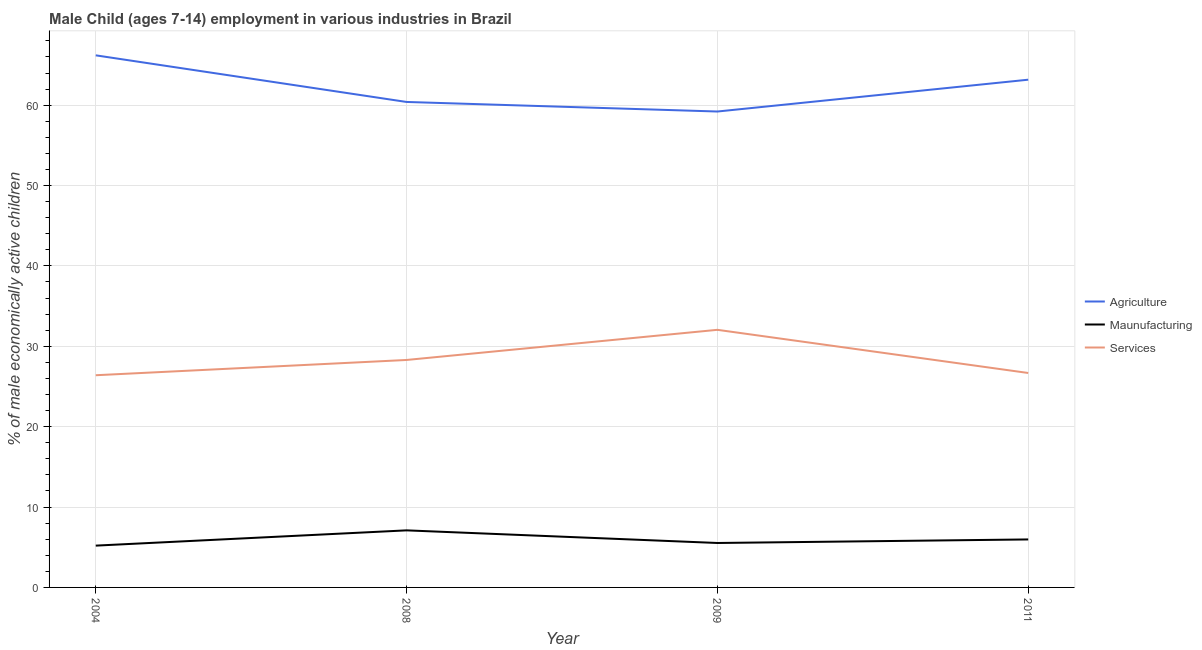What is the percentage of economically active children in agriculture in 2004?
Give a very brief answer. 66.2. Across all years, what is the maximum percentage of economically active children in agriculture?
Provide a short and direct response. 66.2. Across all years, what is the minimum percentage of economically active children in services?
Offer a very short reply. 26.4. What is the total percentage of economically active children in manufacturing in the graph?
Your answer should be very brief. 23.8. What is the difference between the percentage of economically active children in agriculture in 2009 and that in 2011?
Offer a very short reply. -3.96. What is the difference between the percentage of economically active children in agriculture in 2011 and the percentage of economically active children in services in 2009?
Give a very brief answer. 31.12. What is the average percentage of economically active children in agriculture per year?
Provide a short and direct response. 62.25. In the year 2011, what is the difference between the percentage of economically active children in agriculture and percentage of economically active children in manufacturing?
Your response must be concise. 57.2. In how many years, is the percentage of economically active children in services greater than 8 %?
Keep it short and to the point. 4. What is the ratio of the percentage of economically active children in services in 2009 to that in 2011?
Provide a succinct answer. 1.2. Is the difference between the percentage of economically active children in manufacturing in 2004 and 2009 greater than the difference between the percentage of economically active children in services in 2004 and 2009?
Offer a very short reply. Yes. What is the difference between the highest and the second highest percentage of economically active children in services?
Your response must be concise. 3.75. What is the difference between the highest and the lowest percentage of economically active children in manufacturing?
Ensure brevity in your answer.  1.9. In how many years, is the percentage of economically active children in manufacturing greater than the average percentage of economically active children in manufacturing taken over all years?
Offer a very short reply. 2. Is the sum of the percentage of economically active children in agriculture in 2004 and 2011 greater than the maximum percentage of economically active children in manufacturing across all years?
Provide a short and direct response. Yes. Does the percentage of economically active children in manufacturing monotonically increase over the years?
Offer a very short reply. No. Is the percentage of economically active children in services strictly greater than the percentage of economically active children in manufacturing over the years?
Provide a succinct answer. Yes. How many years are there in the graph?
Provide a short and direct response. 4. What is the difference between two consecutive major ticks on the Y-axis?
Keep it short and to the point. 10. Are the values on the major ticks of Y-axis written in scientific E-notation?
Offer a very short reply. No. Does the graph contain any zero values?
Provide a succinct answer. No. Does the graph contain grids?
Provide a short and direct response. Yes. How many legend labels are there?
Your answer should be compact. 3. How are the legend labels stacked?
Your answer should be very brief. Vertical. What is the title of the graph?
Your answer should be very brief. Male Child (ages 7-14) employment in various industries in Brazil. Does "Wage workers" appear as one of the legend labels in the graph?
Keep it short and to the point. No. What is the label or title of the Y-axis?
Provide a short and direct response. % of male economically active children. What is the % of male economically active children in Agriculture in 2004?
Your answer should be compact. 66.2. What is the % of male economically active children in Maunufacturing in 2004?
Provide a short and direct response. 5.2. What is the % of male economically active children of Services in 2004?
Provide a short and direct response. 26.4. What is the % of male economically active children of Agriculture in 2008?
Give a very brief answer. 60.4. What is the % of male economically active children in Maunufacturing in 2008?
Offer a terse response. 7.1. What is the % of male economically active children of Services in 2008?
Your response must be concise. 28.3. What is the % of male economically active children in Agriculture in 2009?
Your answer should be compact. 59.21. What is the % of male economically active children of Maunufacturing in 2009?
Provide a short and direct response. 5.53. What is the % of male economically active children in Services in 2009?
Keep it short and to the point. 32.05. What is the % of male economically active children in Agriculture in 2011?
Your answer should be very brief. 63.17. What is the % of male economically active children of Maunufacturing in 2011?
Offer a very short reply. 5.97. What is the % of male economically active children of Services in 2011?
Make the answer very short. 26.68. Across all years, what is the maximum % of male economically active children of Agriculture?
Give a very brief answer. 66.2. Across all years, what is the maximum % of male economically active children in Maunufacturing?
Your response must be concise. 7.1. Across all years, what is the maximum % of male economically active children of Services?
Keep it short and to the point. 32.05. Across all years, what is the minimum % of male economically active children of Agriculture?
Give a very brief answer. 59.21. Across all years, what is the minimum % of male economically active children of Services?
Your response must be concise. 26.4. What is the total % of male economically active children in Agriculture in the graph?
Offer a terse response. 248.98. What is the total % of male economically active children of Maunufacturing in the graph?
Keep it short and to the point. 23.8. What is the total % of male economically active children of Services in the graph?
Your answer should be compact. 113.43. What is the difference between the % of male economically active children of Agriculture in 2004 and that in 2008?
Offer a terse response. 5.8. What is the difference between the % of male economically active children in Maunufacturing in 2004 and that in 2008?
Your response must be concise. -1.9. What is the difference between the % of male economically active children of Services in 2004 and that in 2008?
Your answer should be compact. -1.9. What is the difference between the % of male economically active children of Agriculture in 2004 and that in 2009?
Your answer should be very brief. 6.99. What is the difference between the % of male economically active children of Maunufacturing in 2004 and that in 2009?
Offer a terse response. -0.33. What is the difference between the % of male economically active children in Services in 2004 and that in 2009?
Your answer should be compact. -5.65. What is the difference between the % of male economically active children of Agriculture in 2004 and that in 2011?
Give a very brief answer. 3.03. What is the difference between the % of male economically active children in Maunufacturing in 2004 and that in 2011?
Ensure brevity in your answer.  -0.77. What is the difference between the % of male economically active children in Services in 2004 and that in 2011?
Offer a terse response. -0.28. What is the difference between the % of male economically active children in Agriculture in 2008 and that in 2009?
Your answer should be very brief. 1.19. What is the difference between the % of male economically active children in Maunufacturing in 2008 and that in 2009?
Provide a succinct answer. 1.57. What is the difference between the % of male economically active children in Services in 2008 and that in 2009?
Your answer should be compact. -3.75. What is the difference between the % of male economically active children in Agriculture in 2008 and that in 2011?
Your answer should be compact. -2.77. What is the difference between the % of male economically active children of Maunufacturing in 2008 and that in 2011?
Provide a short and direct response. 1.13. What is the difference between the % of male economically active children in Services in 2008 and that in 2011?
Your answer should be very brief. 1.62. What is the difference between the % of male economically active children of Agriculture in 2009 and that in 2011?
Make the answer very short. -3.96. What is the difference between the % of male economically active children of Maunufacturing in 2009 and that in 2011?
Your response must be concise. -0.44. What is the difference between the % of male economically active children of Services in 2009 and that in 2011?
Provide a short and direct response. 5.37. What is the difference between the % of male economically active children of Agriculture in 2004 and the % of male economically active children of Maunufacturing in 2008?
Your answer should be very brief. 59.1. What is the difference between the % of male economically active children in Agriculture in 2004 and the % of male economically active children in Services in 2008?
Provide a short and direct response. 37.9. What is the difference between the % of male economically active children of Maunufacturing in 2004 and the % of male economically active children of Services in 2008?
Give a very brief answer. -23.1. What is the difference between the % of male economically active children in Agriculture in 2004 and the % of male economically active children in Maunufacturing in 2009?
Offer a terse response. 60.67. What is the difference between the % of male economically active children in Agriculture in 2004 and the % of male economically active children in Services in 2009?
Offer a very short reply. 34.15. What is the difference between the % of male economically active children in Maunufacturing in 2004 and the % of male economically active children in Services in 2009?
Your answer should be very brief. -26.85. What is the difference between the % of male economically active children in Agriculture in 2004 and the % of male economically active children in Maunufacturing in 2011?
Offer a very short reply. 60.23. What is the difference between the % of male economically active children in Agriculture in 2004 and the % of male economically active children in Services in 2011?
Your response must be concise. 39.52. What is the difference between the % of male economically active children in Maunufacturing in 2004 and the % of male economically active children in Services in 2011?
Offer a terse response. -21.48. What is the difference between the % of male economically active children of Agriculture in 2008 and the % of male economically active children of Maunufacturing in 2009?
Your answer should be compact. 54.87. What is the difference between the % of male economically active children of Agriculture in 2008 and the % of male economically active children of Services in 2009?
Ensure brevity in your answer.  28.35. What is the difference between the % of male economically active children of Maunufacturing in 2008 and the % of male economically active children of Services in 2009?
Your answer should be very brief. -24.95. What is the difference between the % of male economically active children of Agriculture in 2008 and the % of male economically active children of Maunufacturing in 2011?
Your answer should be very brief. 54.43. What is the difference between the % of male economically active children of Agriculture in 2008 and the % of male economically active children of Services in 2011?
Ensure brevity in your answer.  33.72. What is the difference between the % of male economically active children in Maunufacturing in 2008 and the % of male economically active children in Services in 2011?
Offer a terse response. -19.58. What is the difference between the % of male economically active children of Agriculture in 2009 and the % of male economically active children of Maunufacturing in 2011?
Provide a succinct answer. 53.24. What is the difference between the % of male economically active children in Agriculture in 2009 and the % of male economically active children in Services in 2011?
Your answer should be compact. 32.53. What is the difference between the % of male economically active children in Maunufacturing in 2009 and the % of male economically active children in Services in 2011?
Make the answer very short. -21.15. What is the average % of male economically active children in Agriculture per year?
Make the answer very short. 62.24. What is the average % of male economically active children of Maunufacturing per year?
Offer a terse response. 5.95. What is the average % of male economically active children in Services per year?
Offer a terse response. 28.36. In the year 2004, what is the difference between the % of male economically active children of Agriculture and % of male economically active children of Services?
Give a very brief answer. 39.8. In the year 2004, what is the difference between the % of male economically active children in Maunufacturing and % of male economically active children in Services?
Your answer should be very brief. -21.2. In the year 2008, what is the difference between the % of male economically active children in Agriculture and % of male economically active children in Maunufacturing?
Your answer should be compact. 53.3. In the year 2008, what is the difference between the % of male economically active children in Agriculture and % of male economically active children in Services?
Make the answer very short. 32.1. In the year 2008, what is the difference between the % of male economically active children in Maunufacturing and % of male economically active children in Services?
Keep it short and to the point. -21.2. In the year 2009, what is the difference between the % of male economically active children of Agriculture and % of male economically active children of Maunufacturing?
Make the answer very short. 53.68. In the year 2009, what is the difference between the % of male economically active children in Agriculture and % of male economically active children in Services?
Ensure brevity in your answer.  27.16. In the year 2009, what is the difference between the % of male economically active children in Maunufacturing and % of male economically active children in Services?
Offer a very short reply. -26.52. In the year 2011, what is the difference between the % of male economically active children of Agriculture and % of male economically active children of Maunufacturing?
Give a very brief answer. 57.2. In the year 2011, what is the difference between the % of male economically active children in Agriculture and % of male economically active children in Services?
Provide a short and direct response. 36.49. In the year 2011, what is the difference between the % of male economically active children of Maunufacturing and % of male economically active children of Services?
Ensure brevity in your answer.  -20.71. What is the ratio of the % of male economically active children in Agriculture in 2004 to that in 2008?
Your answer should be very brief. 1.1. What is the ratio of the % of male economically active children of Maunufacturing in 2004 to that in 2008?
Provide a short and direct response. 0.73. What is the ratio of the % of male economically active children in Services in 2004 to that in 2008?
Your response must be concise. 0.93. What is the ratio of the % of male economically active children of Agriculture in 2004 to that in 2009?
Give a very brief answer. 1.12. What is the ratio of the % of male economically active children of Maunufacturing in 2004 to that in 2009?
Make the answer very short. 0.94. What is the ratio of the % of male economically active children in Services in 2004 to that in 2009?
Offer a terse response. 0.82. What is the ratio of the % of male economically active children in Agriculture in 2004 to that in 2011?
Offer a very short reply. 1.05. What is the ratio of the % of male economically active children of Maunufacturing in 2004 to that in 2011?
Keep it short and to the point. 0.87. What is the ratio of the % of male economically active children in Services in 2004 to that in 2011?
Keep it short and to the point. 0.99. What is the ratio of the % of male economically active children in Agriculture in 2008 to that in 2009?
Offer a very short reply. 1.02. What is the ratio of the % of male economically active children in Maunufacturing in 2008 to that in 2009?
Keep it short and to the point. 1.28. What is the ratio of the % of male economically active children in Services in 2008 to that in 2009?
Offer a terse response. 0.88. What is the ratio of the % of male economically active children of Agriculture in 2008 to that in 2011?
Provide a short and direct response. 0.96. What is the ratio of the % of male economically active children of Maunufacturing in 2008 to that in 2011?
Offer a very short reply. 1.19. What is the ratio of the % of male economically active children in Services in 2008 to that in 2011?
Your answer should be very brief. 1.06. What is the ratio of the % of male economically active children in Agriculture in 2009 to that in 2011?
Your response must be concise. 0.94. What is the ratio of the % of male economically active children of Maunufacturing in 2009 to that in 2011?
Offer a terse response. 0.93. What is the ratio of the % of male economically active children of Services in 2009 to that in 2011?
Offer a terse response. 1.2. What is the difference between the highest and the second highest % of male economically active children of Agriculture?
Your response must be concise. 3.03. What is the difference between the highest and the second highest % of male economically active children in Maunufacturing?
Provide a short and direct response. 1.13. What is the difference between the highest and the second highest % of male economically active children in Services?
Make the answer very short. 3.75. What is the difference between the highest and the lowest % of male economically active children in Agriculture?
Ensure brevity in your answer.  6.99. What is the difference between the highest and the lowest % of male economically active children of Services?
Your response must be concise. 5.65. 